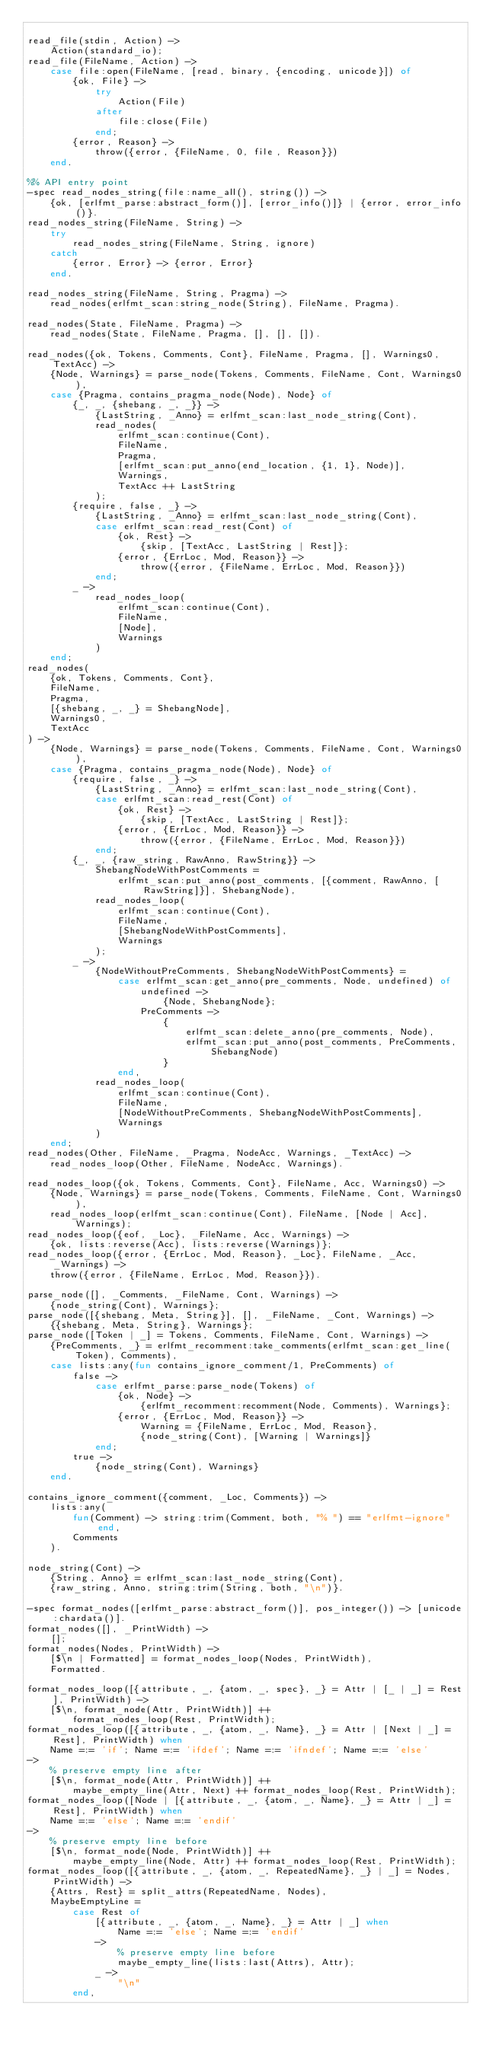<code> <loc_0><loc_0><loc_500><loc_500><_Erlang_>
read_file(stdin, Action) ->
    Action(standard_io);
read_file(FileName, Action) ->
    case file:open(FileName, [read, binary, {encoding, unicode}]) of
        {ok, File} ->
            try
                Action(File)
            after
                file:close(File)
            end;
        {error, Reason} ->
            throw({error, {FileName, 0, file, Reason}})
    end.

%% API entry point
-spec read_nodes_string(file:name_all(), string()) ->
    {ok, [erlfmt_parse:abstract_form()], [error_info()]} | {error, error_info()}.
read_nodes_string(FileName, String) ->
    try
        read_nodes_string(FileName, String, ignore)
    catch
        {error, Error} -> {error, Error}
    end.

read_nodes_string(FileName, String, Pragma) ->
    read_nodes(erlfmt_scan:string_node(String), FileName, Pragma).

read_nodes(State, FileName, Pragma) ->
    read_nodes(State, FileName, Pragma, [], [], []).

read_nodes({ok, Tokens, Comments, Cont}, FileName, Pragma, [], Warnings0, TextAcc) ->
    {Node, Warnings} = parse_node(Tokens, Comments, FileName, Cont, Warnings0),
    case {Pragma, contains_pragma_node(Node), Node} of
        {_, _, {shebang, _, _}} ->
            {LastString, _Anno} = erlfmt_scan:last_node_string(Cont),
            read_nodes(
                erlfmt_scan:continue(Cont),
                FileName,
                Pragma,
                [erlfmt_scan:put_anno(end_location, {1, 1}, Node)],
                Warnings,
                TextAcc ++ LastString
            );
        {require, false, _} ->
            {LastString, _Anno} = erlfmt_scan:last_node_string(Cont),
            case erlfmt_scan:read_rest(Cont) of
                {ok, Rest} ->
                    {skip, [TextAcc, LastString | Rest]};
                {error, {ErrLoc, Mod, Reason}} ->
                    throw({error, {FileName, ErrLoc, Mod, Reason}})
            end;
        _ ->
            read_nodes_loop(
                erlfmt_scan:continue(Cont),
                FileName,
                [Node],
                Warnings
            )
    end;
read_nodes(
    {ok, Tokens, Comments, Cont},
    FileName,
    Pragma,
    [{shebang, _, _} = ShebangNode],
    Warnings0,
    TextAcc
) ->
    {Node, Warnings} = parse_node(Tokens, Comments, FileName, Cont, Warnings0),
    case {Pragma, contains_pragma_node(Node), Node} of
        {require, false, _} ->
            {LastString, _Anno} = erlfmt_scan:last_node_string(Cont),
            case erlfmt_scan:read_rest(Cont) of
                {ok, Rest} ->
                    {skip, [TextAcc, LastString | Rest]};
                {error, {ErrLoc, Mod, Reason}} ->
                    throw({error, {FileName, ErrLoc, Mod, Reason}})
            end;
        {_, _, {raw_string, RawAnno, RawString}} ->
            ShebangNodeWithPostComments =
                erlfmt_scan:put_anno(post_comments, [{comment, RawAnno, [RawString]}], ShebangNode),
            read_nodes_loop(
                erlfmt_scan:continue(Cont),
                FileName,
                [ShebangNodeWithPostComments],
                Warnings
            );
        _ ->
            {NodeWithoutPreComments, ShebangNodeWithPostComments} =
                case erlfmt_scan:get_anno(pre_comments, Node, undefined) of
                    undefined ->
                        {Node, ShebangNode};
                    PreComments ->
                        {
                            erlfmt_scan:delete_anno(pre_comments, Node),
                            erlfmt_scan:put_anno(post_comments, PreComments, ShebangNode)
                        }
                end,
            read_nodes_loop(
                erlfmt_scan:continue(Cont),
                FileName,
                [NodeWithoutPreComments, ShebangNodeWithPostComments],
                Warnings
            )
    end;
read_nodes(Other, FileName, _Pragma, NodeAcc, Warnings, _TextAcc) ->
    read_nodes_loop(Other, FileName, NodeAcc, Warnings).

read_nodes_loop({ok, Tokens, Comments, Cont}, FileName, Acc, Warnings0) ->
    {Node, Warnings} = parse_node(Tokens, Comments, FileName, Cont, Warnings0),
    read_nodes_loop(erlfmt_scan:continue(Cont), FileName, [Node | Acc], Warnings);
read_nodes_loop({eof, _Loc}, _FileName, Acc, Warnings) ->
    {ok, lists:reverse(Acc), lists:reverse(Warnings)};
read_nodes_loop({error, {ErrLoc, Mod, Reason}, _Loc}, FileName, _Acc, _Warnings) ->
    throw({error, {FileName, ErrLoc, Mod, Reason}}).

parse_node([], _Comments, _FileName, Cont, Warnings) ->
    {node_string(Cont), Warnings};
parse_node([{shebang, Meta, String}], [], _FileName, _Cont, Warnings) ->
    {{shebang, Meta, String}, Warnings};
parse_node([Token | _] = Tokens, Comments, FileName, Cont, Warnings) ->
    {PreComments, _} = erlfmt_recomment:take_comments(erlfmt_scan:get_line(Token), Comments),
    case lists:any(fun contains_ignore_comment/1, PreComments) of
        false ->
            case erlfmt_parse:parse_node(Tokens) of
                {ok, Node} ->
                    {erlfmt_recomment:recomment(Node, Comments), Warnings};
                {error, {ErrLoc, Mod, Reason}} ->
                    Warning = {FileName, ErrLoc, Mod, Reason},
                    {node_string(Cont), [Warning | Warnings]}
            end;
        true ->
            {node_string(Cont), Warnings}
    end.

contains_ignore_comment({comment, _Loc, Comments}) ->
    lists:any(
        fun(Comment) -> string:trim(Comment, both, "% ") == "erlfmt-ignore" end,
        Comments
    ).

node_string(Cont) ->
    {String, Anno} = erlfmt_scan:last_node_string(Cont),
    {raw_string, Anno, string:trim(String, both, "\n")}.

-spec format_nodes([erlfmt_parse:abstract_form()], pos_integer()) -> [unicode:chardata()].
format_nodes([], _PrintWidth) ->
    [];
format_nodes(Nodes, PrintWidth) ->
    [$\n | Formatted] = format_nodes_loop(Nodes, PrintWidth),
    Formatted.

format_nodes_loop([{attribute, _, {atom, _, spec}, _} = Attr | [_ | _] = Rest], PrintWidth) ->
    [$\n, format_node(Attr, PrintWidth)] ++
        format_nodes_loop(Rest, PrintWidth);
format_nodes_loop([{attribute, _, {atom, _, Name}, _} = Attr | [Next | _] = Rest], PrintWidth) when
    Name =:= 'if'; Name =:= 'ifdef'; Name =:= 'ifndef'; Name =:= 'else'
->
    % preserve empty line after
    [$\n, format_node(Attr, PrintWidth)] ++
        maybe_empty_line(Attr, Next) ++ format_nodes_loop(Rest, PrintWidth);
format_nodes_loop([Node | [{attribute, _, {atom, _, Name}, _} = Attr | _] = Rest], PrintWidth) when
    Name =:= 'else'; Name =:= 'endif'
->
    % preserve empty line before
    [$\n, format_node(Node, PrintWidth)] ++
        maybe_empty_line(Node, Attr) ++ format_nodes_loop(Rest, PrintWidth);
format_nodes_loop([{attribute, _, {atom, _, RepeatedName}, _} | _] = Nodes, PrintWidth) ->
    {Attrs, Rest} = split_attrs(RepeatedName, Nodes),
    MaybeEmptyLine =
        case Rest of
            [{attribute, _, {atom, _, Name}, _} = Attr | _] when
                Name =:= 'else'; Name =:= 'endif'
            ->
                % preserve empty line before
                maybe_empty_line(lists:last(Attrs), Attr);
            _ ->
                "\n"
        end,</code> 